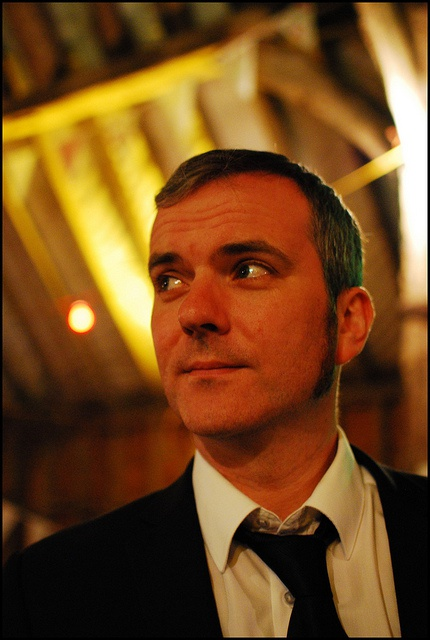Describe the objects in this image and their specific colors. I can see people in black, brown, and maroon tones and tie in black, maroon, olive, and gray tones in this image. 